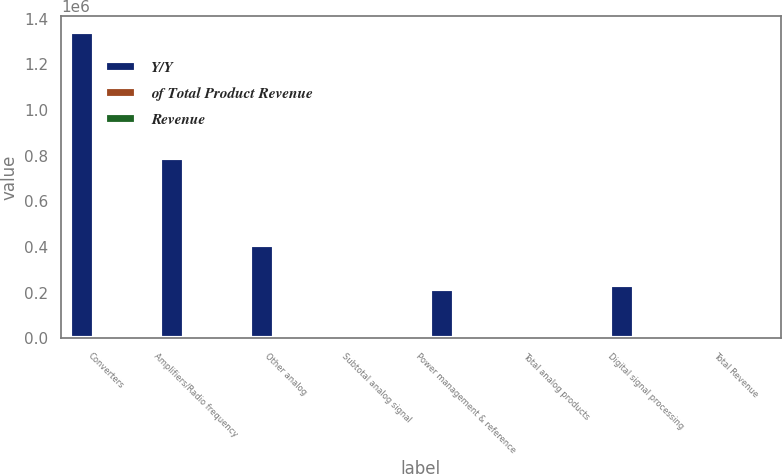<chart> <loc_0><loc_0><loc_500><loc_500><stacked_bar_chart><ecel><fcel>Converters<fcel>Amplifiers/Radio frequency<fcel>Other analog<fcel>Subtotal analog signal<fcel>Power management & reference<fcel>Total analog products<fcel>Digital signal processing<fcel>Total Revenue<nl><fcel>Y/Y<fcel>1.34349e+06<fcel>788498<fcel>410233<fcel>23<fcel>217501<fcel>23<fcel>233596<fcel>23<nl><fcel>of Total Product Revenue<fcel>45<fcel>26<fcel>14<fcel>85<fcel>7<fcel>92<fcel>8<fcel>100<nl><fcel>Revenue<fcel>4<fcel>12<fcel>23<fcel>9<fcel>12<fcel>9<fcel>1<fcel>8<nl></chart> 